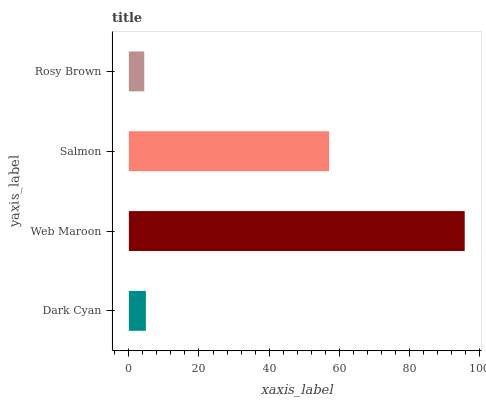Is Rosy Brown the minimum?
Answer yes or no. Yes. Is Web Maroon the maximum?
Answer yes or no. Yes. Is Salmon the minimum?
Answer yes or no. No. Is Salmon the maximum?
Answer yes or no. No. Is Web Maroon greater than Salmon?
Answer yes or no. Yes. Is Salmon less than Web Maroon?
Answer yes or no. Yes. Is Salmon greater than Web Maroon?
Answer yes or no. No. Is Web Maroon less than Salmon?
Answer yes or no. No. Is Salmon the high median?
Answer yes or no. Yes. Is Dark Cyan the low median?
Answer yes or no. Yes. Is Web Maroon the high median?
Answer yes or no. No. Is Web Maroon the low median?
Answer yes or no. No. 